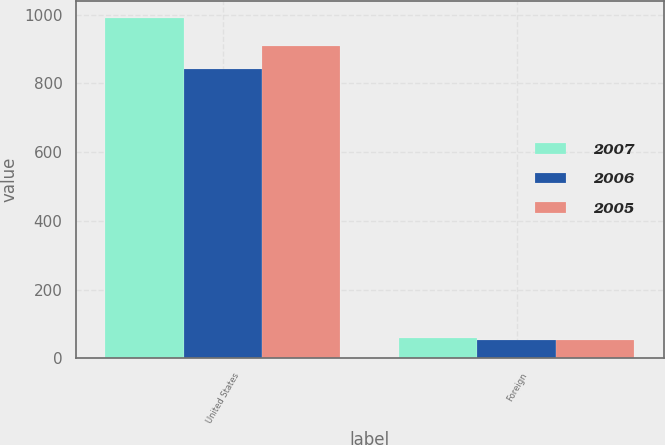Convert chart. <chart><loc_0><loc_0><loc_500><loc_500><stacked_bar_chart><ecel><fcel>United States<fcel>Foreign<nl><fcel>2007<fcel>991.5<fcel>58<nl><fcel>2006<fcel>842.6<fcel>52.7<nl><fcel>2005<fcel>909.2<fcel>53.2<nl></chart> 